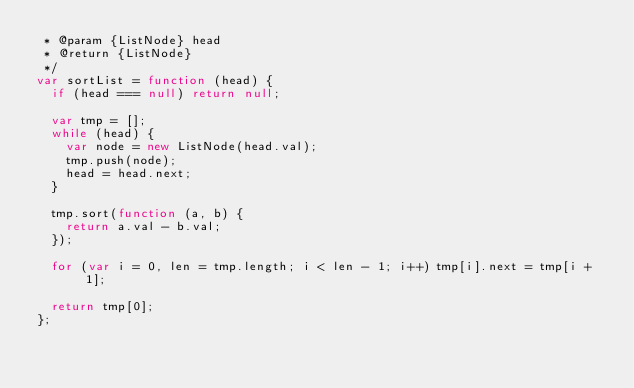Convert code to text. <code><loc_0><loc_0><loc_500><loc_500><_JavaScript_> * @param {ListNode} head
 * @return {ListNode}
 */
var sortList = function (head) {
  if (head === null) return null;

  var tmp = [];
  while (head) {
    var node = new ListNode(head.val);
    tmp.push(node);
    head = head.next;
  }

  tmp.sort(function (a, b) {
    return a.val - b.val;
  });

  for (var i = 0, len = tmp.length; i < len - 1; i++) tmp[i].next = tmp[i + 1];

  return tmp[0];
};
</code> 